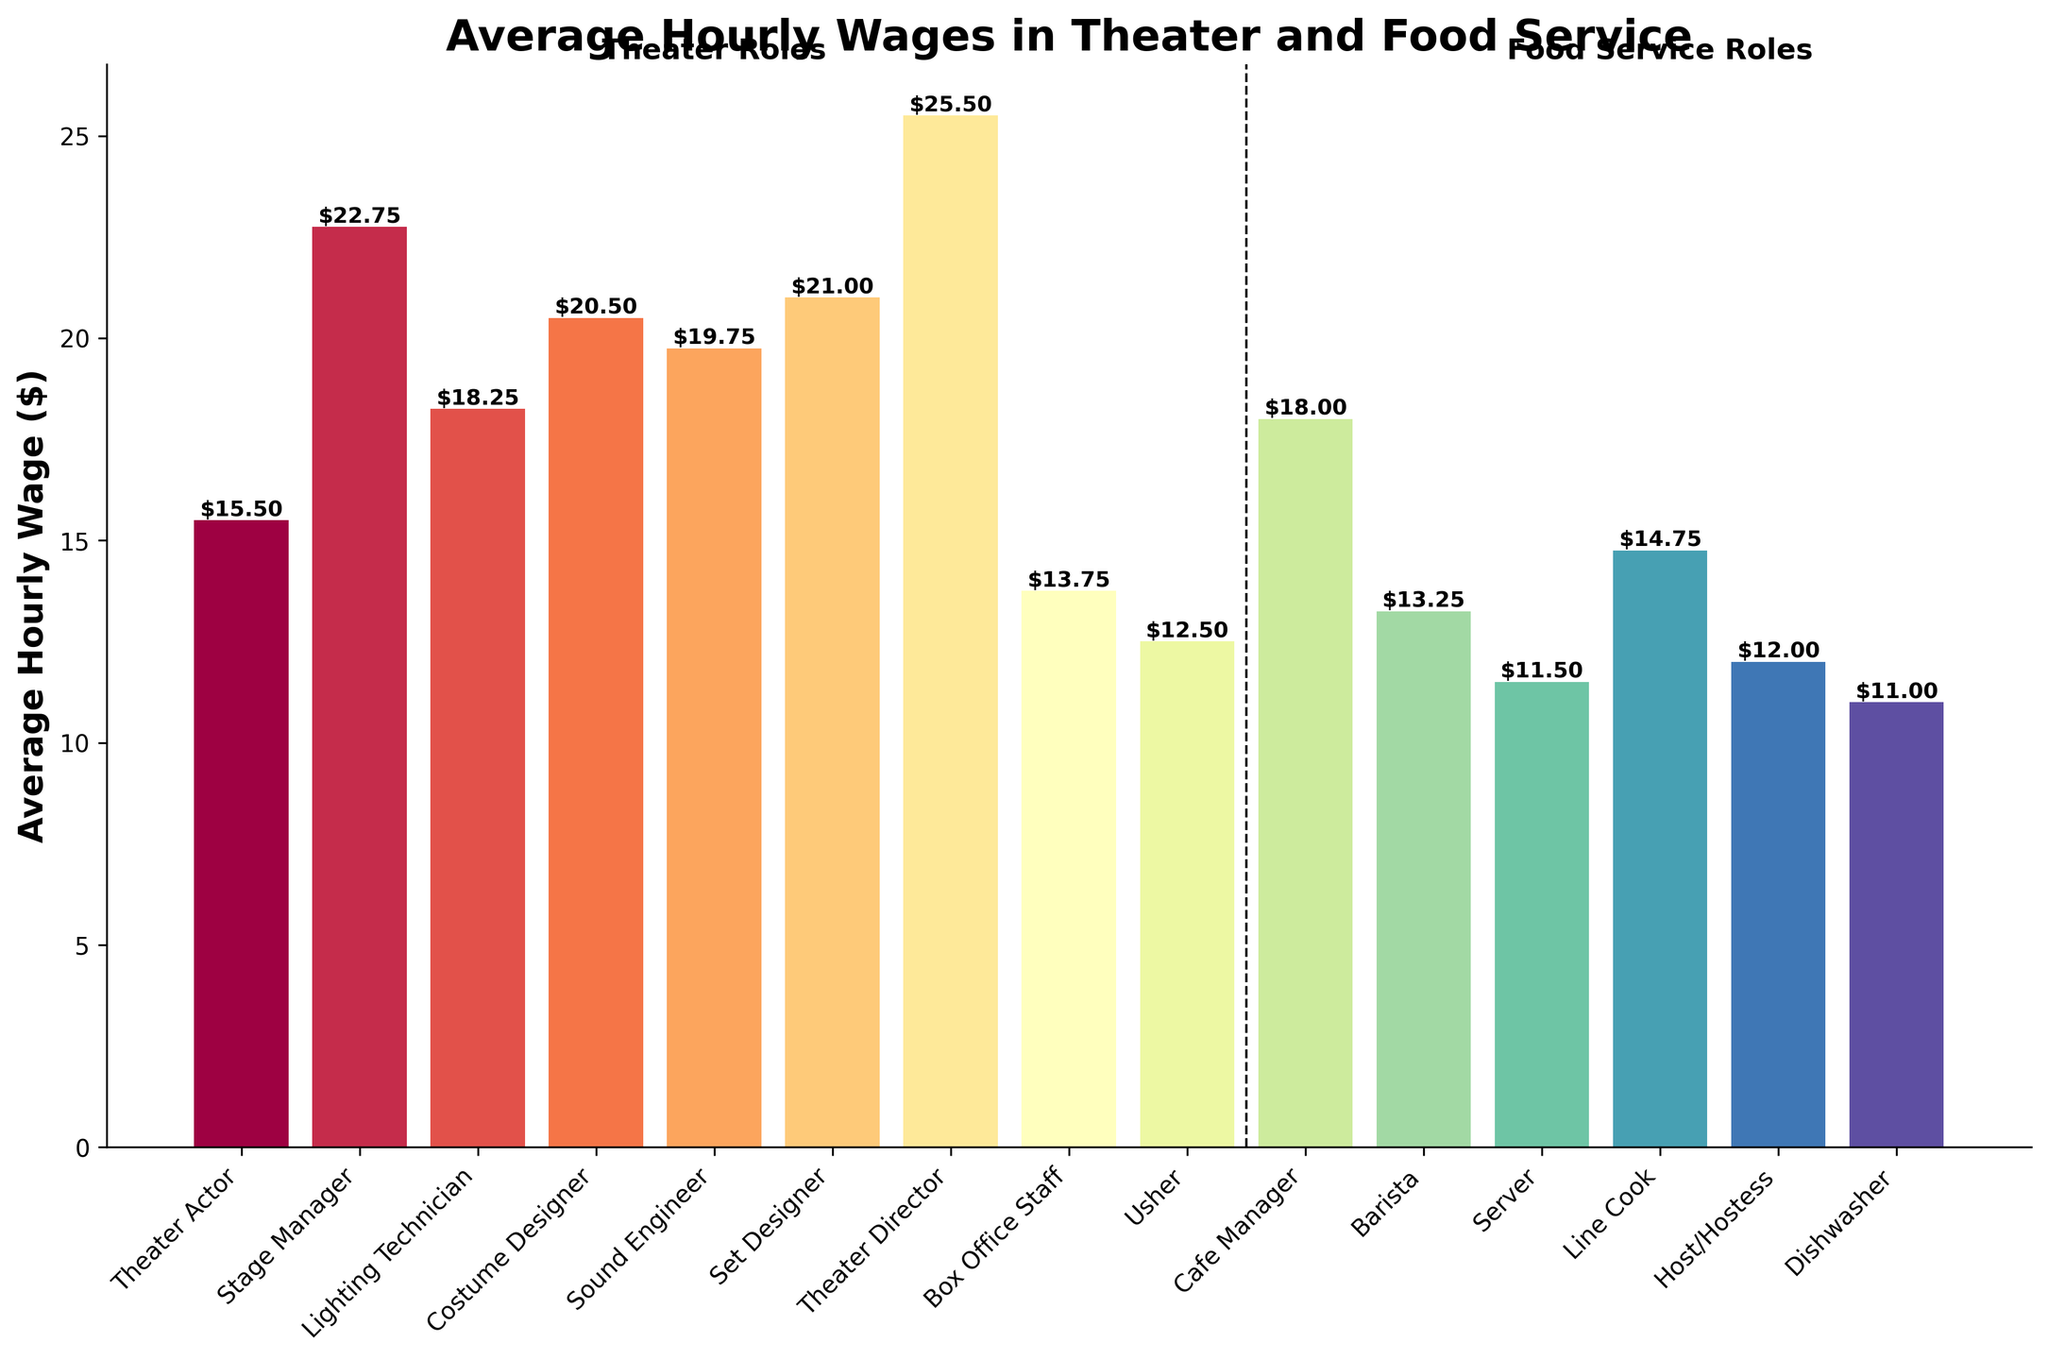What is the highest average hourly wage among the roles in the theater industry? Looking at the tallest bars in the 'Theater Roles' section, the bar labeled 'Theater Director' has the highest value. The exact height marked on the bar is $25.50.
Answer: $25.50 Which role has a higher average hourly wage: Lighting Technician or Sound Engineer? Comparing the heights of the bars for 'Lighting Technician' and 'Sound Engineer,' the 'Sound Engineer' bar is taller. The exact values marked on the bars are $18.25 for Lighting Technician and $19.75 for Sound Engineer.
Answer: Sound Engineer What is the difference in average hourly wage between a Barista and a Line Cook? The bar for 'Barista' is labeled $13.25, and the bar for 'Line Cook' is labeled $14.75. Subtracting $13.25 from $14.75 gives $1.50.
Answer: $1.50 How does the average hourly wage of a Theater Actor compare to a Cafe Manager? Comparing the heights of the bars for 'Theater Actor' and 'Cafe Manager,' they are roughly similar but not exactly equal. The exact values are $15.50 for Theater Actor and $18.00 for Cafe Manager.
Answer: Cafe Manager earns more What is the average hourly wage for the roles in the food service industry? To find the average, sum the wages for 'Cafe Manager' ($18.00), 'Barista' ($13.25), 'Server' ($11.50), 'Line Cook' ($14.75), 'Host/Hostess' ($12.00), and 'Dishwasher' ($11.00) and divide by 6. Sum = 80.5, Average = 80.5/6 ≈ 13.42
Answer: $13.42 Which has the lowest wage, Usher or Dishwasher? Comparing the bars for 'Usher' and 'Dishwasher,' the 'Dishwasher' bar is shorter. The exact values are $12.50 for Usher and $11.00 for Dishwasher.
Answer: Dishwasher Is there a role in the theater industry that earns more than the Cafe Manager? Yes, by checking the bars in the Theater Roles section and comparing them to the bar for the Cafe Manager, which is $18.00, we can see that several roles earn more. These include Stage Manager ($22.75), Costume Designer ($20.50), Sound Engineer ($19.75), Set Designer ($21.00), and Theater Director ($25.50).
Answer: Multiple roles earn more Calculate the total average hourly wages for all roles in the theater industry. Sum the wages for the theater roles: ($15.50 + $22.75 + $18.25 + $20.50 + $19.75 + $21.00 + $25.50 + $13.75 + $12.50). Total = $169.50.
Answer: $169.50 Which visual section (Theater Roles or Food Service Roles) has the bar with the lowest average hourly wage? The lowest bar in the 'Food Service Roles' section is 'Dishwasher' at $11.00. In the 'Theater Roles' section, the lowest is 'Usher' at $12.50. Therefore, the 'Food Service Roles' section contains the bar with the lowest average hourly wage.
Answer: Food Service Roles Compare the total wages for Theater Director, Cafe Manager, and Barista. Which one has the highest total? Summing the average hourly wages for each: Theater Director ($25.50), Cafe Manager ($18.00), Barista ($13.25). The Theater Director has the highest wage.
Answer: Theater Director 